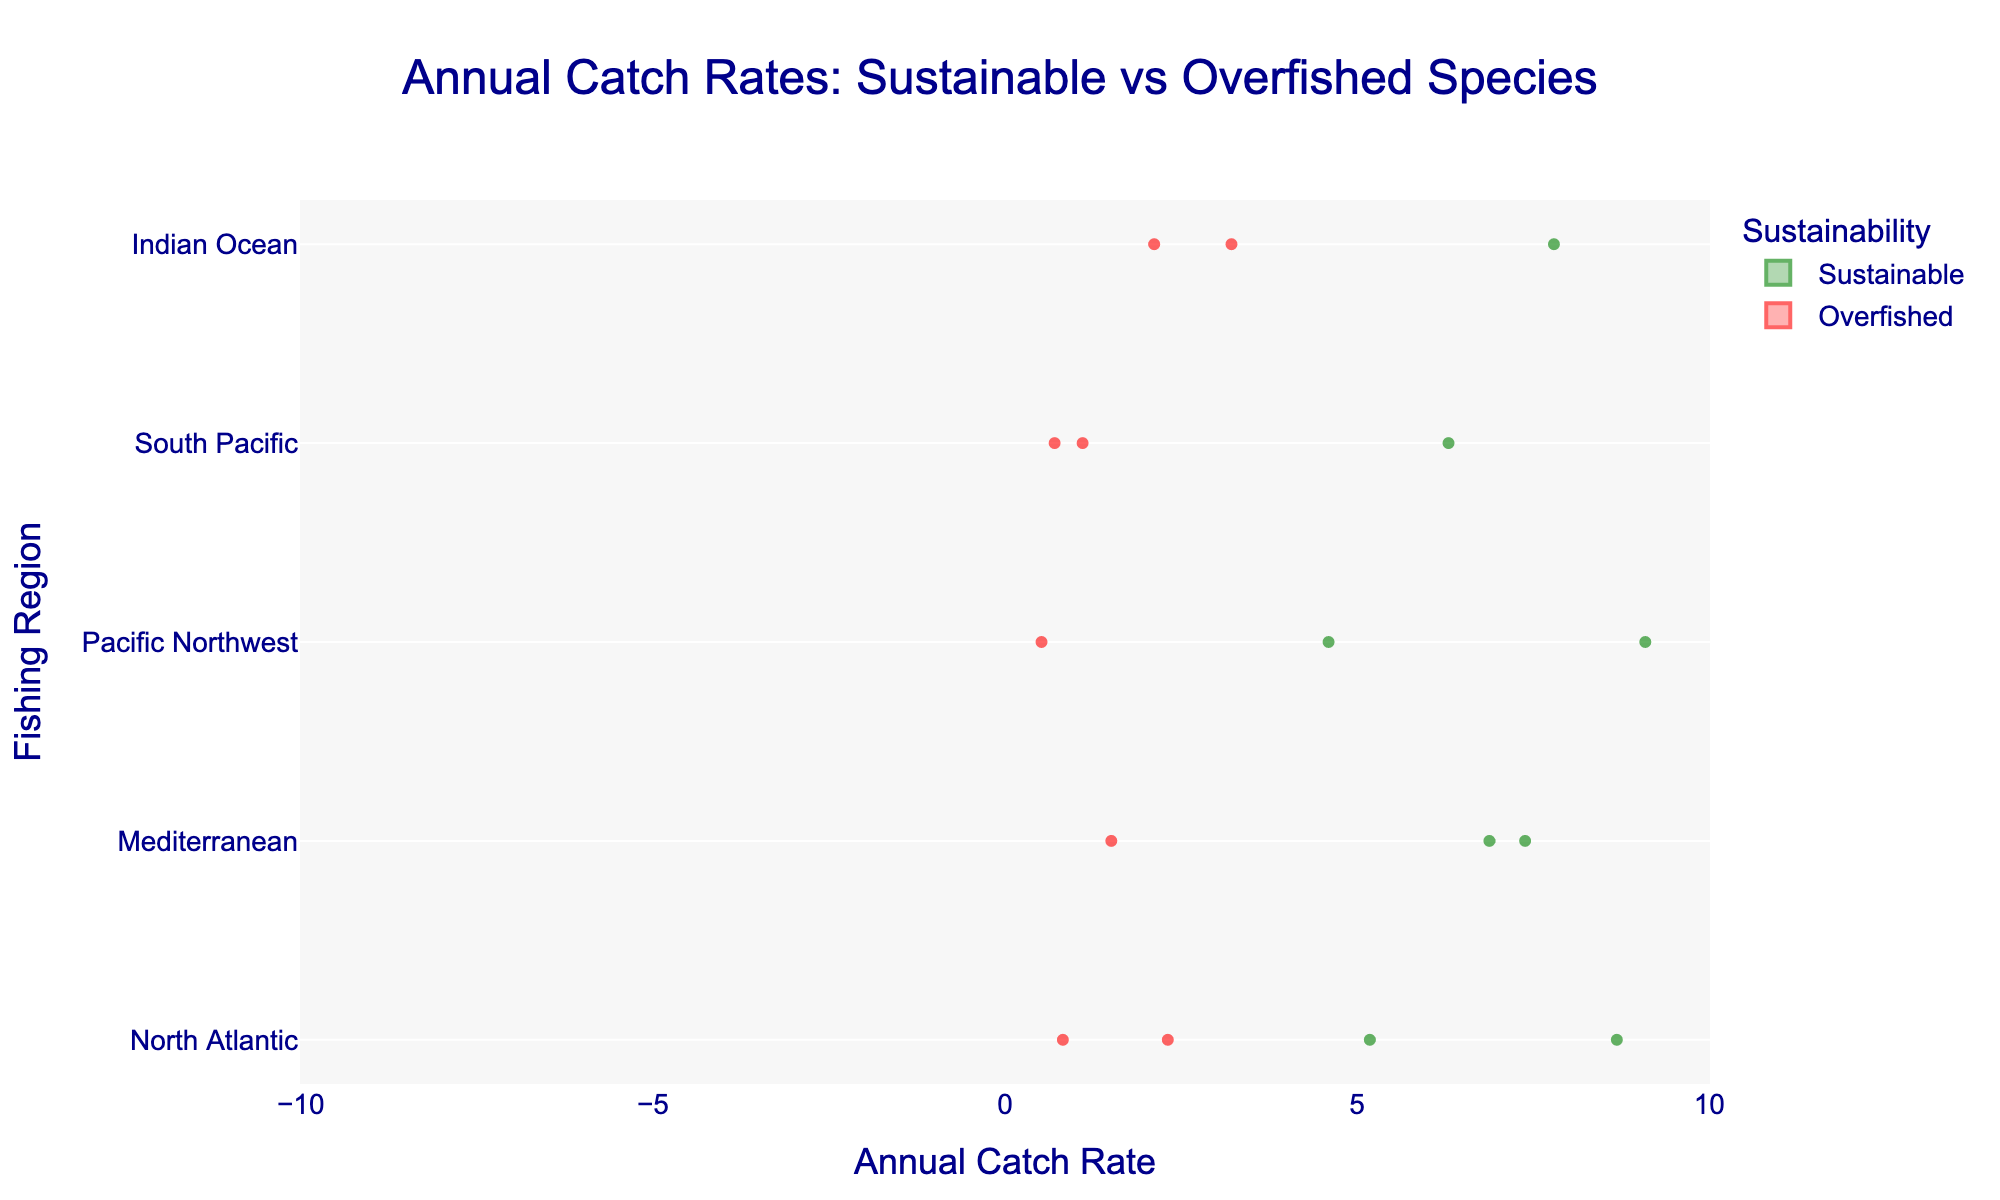How many regions are represented in the plot? The y-axis of the plot shows the different fishing regions. By counting the entries, we see there are five regions: North Atlantic, Mediterranean, Pacific Northwest, South Pacific, and Indian Ocean.
Answer: Five Which region has the highest median annual catch rate for sustainable species? By observing the violin plots for the sustainable species, the Pacific Northwest region shows the highest median line compared to other regions.
Answer: Pacific Northwest How do the annual catch rates of sustainable and overfished species compare in the Indian Ocean? For the Indian Ocean, the violin plot for sustainable species (Skipjack Tuna) is larger and positioned more to the right along the x-axis compared to the overfished species (Yellowfin Tuna and Bigeye Tuna). This indicates higher catch rates for sustainable species.
Answer: Higher for sustainable species What is the average annual catch rate of overfished species in the South Pacific? In the South Pacific region, overfished species include Orange Roughy (0.7) and Southern Bluefin Tuna (1.1). The average is calculated as (0.7 + 1.1) / 2.
Answer: 0.9 Which sustainability category shows more variability in annual catch rates in the Mediterranean? In the Mediterranean region, the violin plot for sustainable species shows a wider spread than the plot for overfished species, indicating higher variability.
Answer: Sustainable Compare the median annual catch rates of sustainable species between the North Atlantic and South Pacific. The median annual catch rates are shown by the horizontal lines in the violin plots. The North Atlantic has a median line around 6 (Haddock), while the South Pacific has a median around 6.3 (New Zealand Hoki).
Answer: South Pacific higher Identify the region with the least variation in annual catch rates for overfished species. By observing the width and spread of the violin plots for overfished species, the South Pacific (Orange Roughy, Southern Bluefin Tuna) shows the least variation as the plots are more concentrated and narrower.
Answer: South Pacific What is the total number of sustainable species represented in the plot? Each violin plot represents unique species; counting the boxes for sustainable species across all regions: Atlantic Herring, Haddock, European Anchovy, Sardine, Alaska Pollock, Pacific Halibut, New Zealand Hoki, and Skipjack Tuna.
Answer: Eight 